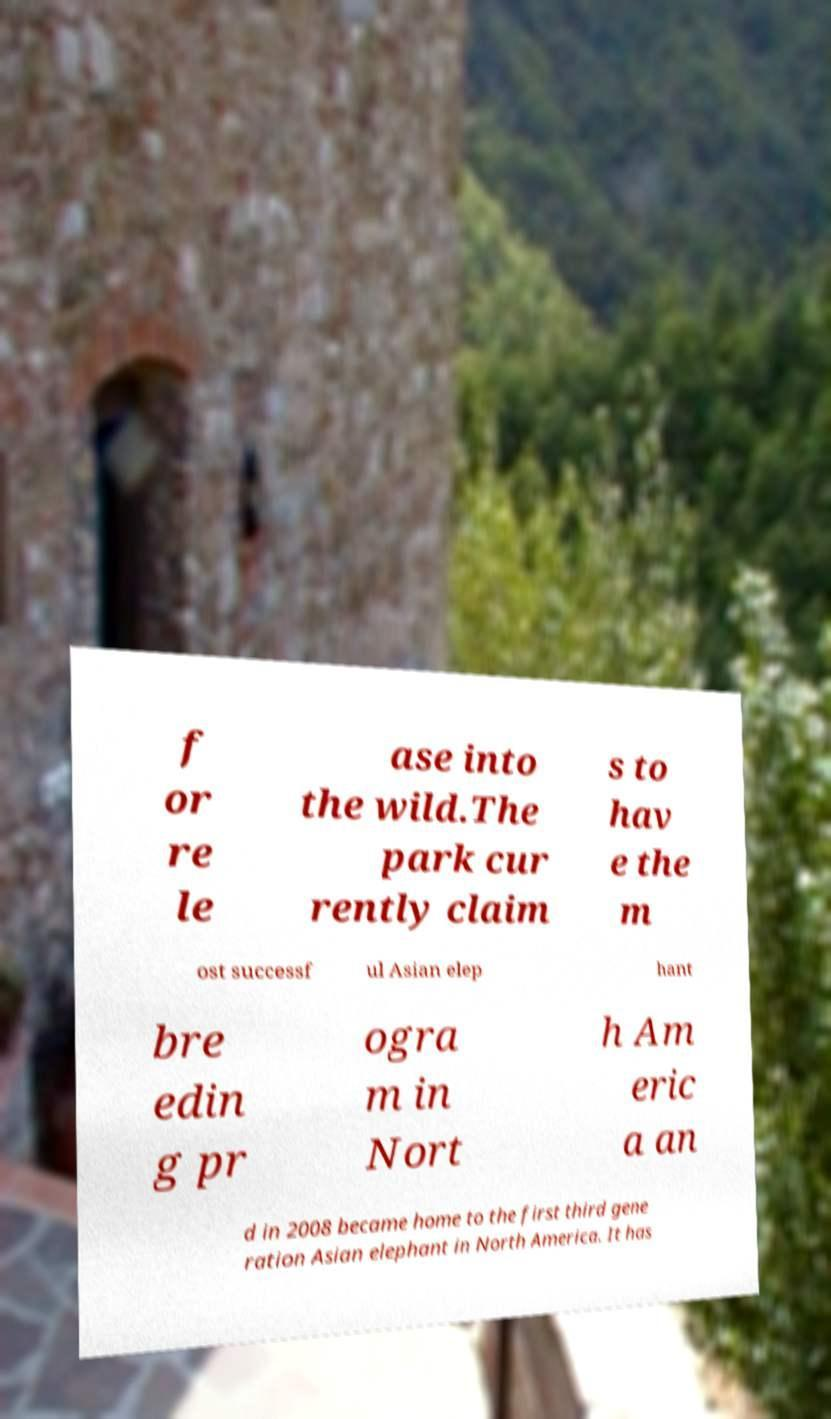There's text embedded in this image that I need extracted. Can you transcribe it verbatim? f or re le ase into the wild.The park cur rently claim s to hav e the m ost successf ul Asian elep hant bre edin g pr ogra m in Nort h Am eric a an d in 2008 became home to the first third gene ration Asian elephant in North America. It has 